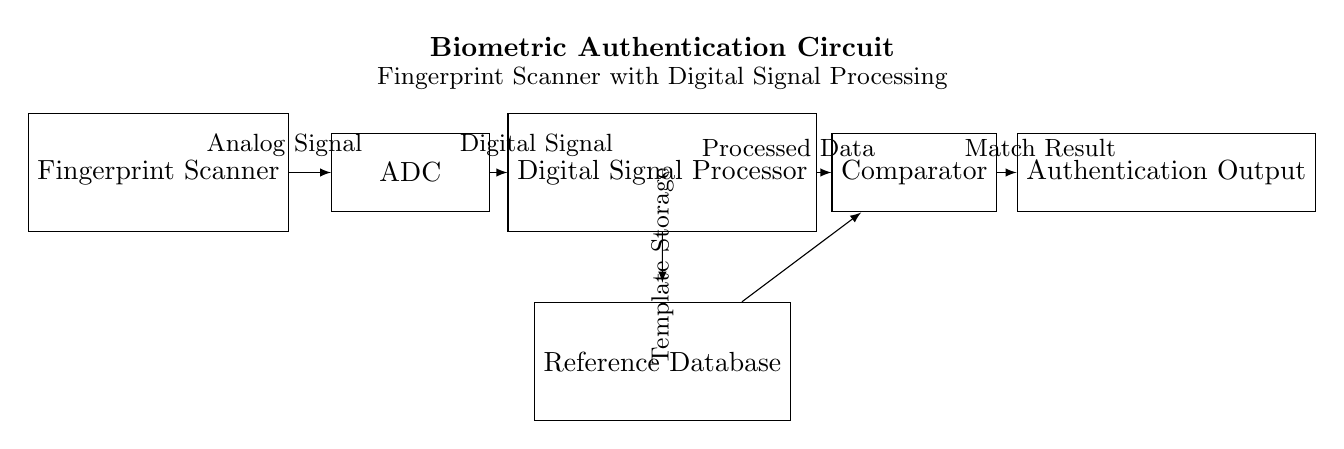What are the main components in the circuit? The circuit includes a fingerprint scanner, ADC, digital signal processor, reference database, comparator, and authentication output. Each of these components plays a role in the fingerprint authentication process, from capturing the fingerprint to outputting the authentication result.
Answer: Fingerprint Scanner, ADC, DSP, Reference Database, Comparator, Authentication Output What is the direction of the data flow in the circuit? Data flows from the fingerprint scanner to the ADC, then to the digital signal processor, followed by the comparator and finally reaches the authentication output. This sequence indicates the progression of the fingerprint information being processed for authentication.
Answer: From Fingerprint Scanner to Authentication Output What type of signal is processed first in this circuit? The first signal processed is an analog signal from the fingerprint scanner. This is indicated by the connection leading from the scanner to the ADC, which converts the analog signal into a digital format for further processing.
Answer: Analog Signal How does the digital signal processor utilize the reference database? The digital signal processor compares the processed data it receives from the ADC with the stored templates in the reference database to determine if there is a match, ultimately leading to the authentication output.
Answer: For matching fingerprints What is the role of the comparator in the circuit? The comparator is responsible for analyzing the processed data from the digital signal processor against the reference data from the database to output a match result. The role of the comparator is crucial as it decides the correctness of the match and produces the final authentication result.
Answer: To analyze for a match Which component provides the template storage? The template storage is provided by the reference database, which holds the fingerprint templates necessary for comparison against the incoming processed data from the digital signal processor.
Answer: Reference Database 